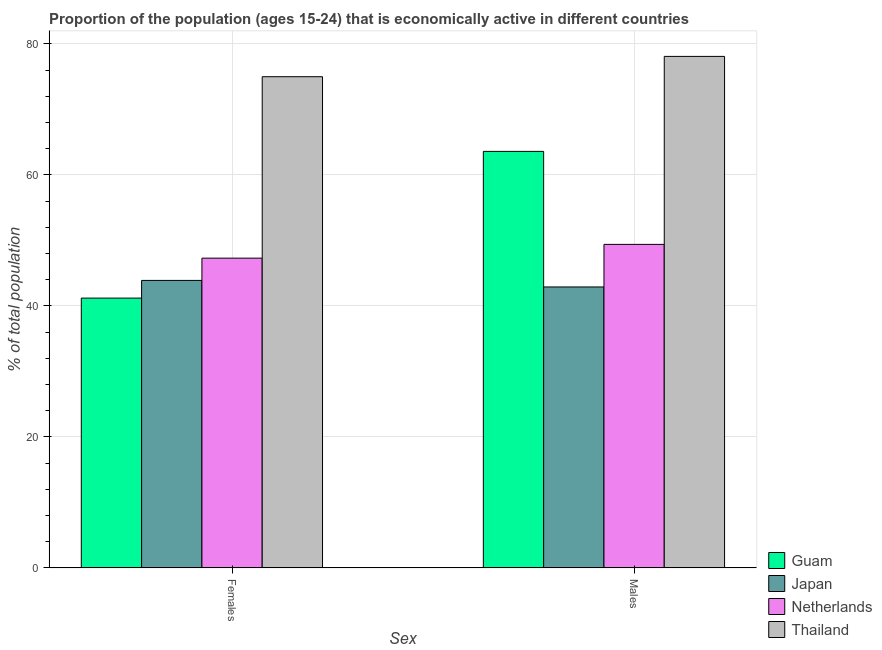How many different coloured bars are there?
Ensure brevity in your answer.  4. Are the number of bars per tick equal to the number of legend labels?
Make the answer very short. Yes. How many bars are there on the 1st tick from the left?
Keep it short and to the point. 4. What is the label of the 2nd group of bars from the left?
Your response must be concise. Males. What is the percentage of economically active male population in Japan?
Provide a short and direct response. 42.9. Across all countries, what is the maximum percentage of economically active male population?
Offer a very short reply. 78.1. Across all countries, what is the minimum percentage of economically active male population?
Ensure brevity in your answer.  42.9. In which country was the percentage of economically active male population maximum?
Provide a short and direct response. Thailand. In which country was the percentage of economically active female population minimum?
Ensure brevity in your answer.  Guam. What is the total percentage of economically active female population in the graph?
Your answer should be very brief. 207.4. What is the difference between the percentage of economically active female population in Thailand and that in Japan?
Your answer should be compact. 31.1. What is the average percentage of economically active male population per country?
Keep it short and to the point. 58.5. In how many countries, is the percentage of economically active female population greater than 8 %?
Ensure brevity in your answer.  4. What is the ratio of the percentage of economically active male population in Japan to that in Guam?
Ensure brevity in your answer.  0.67. In how many countries, is the percentage of economically active female population greater than the average percentage of economically active female population taken over all countries?
Provide a short and direct response. 1. What does the 1st bar from the left in Females represents?
Provide a short and direct response. Guam. What does the 3rd bar from the right in Males represents?
Your answer should be very brief. Japan. How many bars are there?
Offer a terse response. 8. Are the values on the major ticks of Y-axis written in scientific E-notation?
Keep it short and to the point. No. Where does the legend appear in the graph?
Your answer should be very brief. Bottom right. How are the legend labels stacked?
Provide a short and direct response. Vertical. What is the title of the graph?
Your answer should be compact. Proportion of the population (ages 15-24) that is economically active in different countries. What is the label or title of the X-axis?
Your answer should be compact. Sex. What is the label or title of the Y-axis?
Ensure brevity in your answer.  % of total population. What is the % of total population of Guam in Females?
Your answer should be very brief. 41.2. What is the % of total population of Japan in Females?
Your answer should be very brief. 43.9. What is the % of total population in Netherlands in Females?
Make the answer very short. 47.3. What is the % of total population in Guam in Males?
Offer a terse response. 63.6. What is the % of total population in Japan in Males?
Give a very brief answer. 42.9. What is the % of total population of Netherlands in Males?
Your response must be concise. 49.4. What is the % of total population of Thailand in Males?
Offer a terse response. 78.1. Across all Sex, what is the maximum % of total population of Guam?
Offer a very short reply. 63.6. Across all Sex, what is the maximum % of total population of Japan?
Give a very brief answer. 43.9. Across all Sex, what is the maximum % of total population of Netherlands?
Your answer should be compact. 49.4. Across all Sex, what is the maximum % of total population in Thailand?
Provide a succinct answer. 78.1. Across all Sex, what is the minimum % of total population in Guam?
Offer a very short reply. 41.2. Across all Sex, what is the minimum % of total population in Japan?
Ensure brevity in your answer.  42.9. Across all Sex, what is the minimum % of total population in Netherlands?
Provide a succinct answer. 47.3. Across all Sex, what is the minimum % of total population in Thailand?
Ensure brevity in your answer.  75. What is the total % of total population of Guam in the graph?
Provide a succinct answer. 104.8. What is the total % of total population in Japan in the graph?
Offer a very short reply. 86.8. What is the total % of total population in Netherlands in the graph?
Ensure brevity in your answer.  96.7. What is the total % of total population of Thailand in the graph?
Keep it short and to the point. 153.1. What is the difference between the % of total population in Guam in Females and that in Males?
Your answer should be very brief. -22.4. What is the difference between the % of total population in Guam in Females and the % of total population in Japan in Males?
Make the answer very short. -1.7. What is the difference between the % of total population in Guam in Females and the % of total population in Netherlands in Males?
Make the answer very short. -8.2. What is the difference between the % of total population of Guam in Females and the % of total population of Thailand in Males?
Keep it short and to the point. -36.9. What is the difference between the % of total population in Japan in Females and the % of total population in Thailand in Males?
Ensure brevity in your answer.  -34.2. What is the difference between the % of total population in Netherlands in Females and the % of total population in Thailand in Males?
Give a very brief answer. -30.8. What is the average % of total population in Guam per Sex?
Provide a succinct answer. 52.4. What is the average % of total population in Japan per Sex?
Your answer should be very brief. 43.4. What is the average % of total population in Netherlands per Sex?
Give a very brief answer. 48.35. What is the average % of total population in Thailand per Sex?
Your answer should be compact. 76.55. What is the difference between the % of total population of Guam and % of total population of Japan in Females?
Provide a succinct answer. -2.7. What is the difference between the % of total population in Guam and % of total population in Netherlands in Females?
Ensure brevity in your answer.  -6.1. What is the difference between the % of total population in Guam and % of total population in Thailand in Females?
Offer a very short reply. -33.8. What is the difference between the % of total population in Japan and % of total population in Thailand in Females?
Offer a terse response. -31.1. What is the difference between the % of total population in Netherlands and % of total population in Thailand in Females?
Provide a short and direct response. -27.7. What is the difference between the % of total population in Guam and % of total population in Japan in Males?
Provide a succinct answer. 20.7. What is the difference between the % of total population of Japan and % of total population of Netherlands in Males?
Make the answer very short. -6.5. What is the difference between the % of total population of Japan and % of total population of Thailand in Males?
Give a very brief answer. -35.2. What is the difference between the % of total population in Netherlands and % of total population in Thailand in Males?
Provide a succinct answer. -28.7. What is the ratio of the % of total population of Guam in Females to that in Males?
Offer a terse response. 0.65. What is the ratio of the % of total population of Japan in Females to that in Males?
Ensure brevity in your answer.  1.02. What is the ratio of the % of total population in Netherlands in Females to that in Males?
Provide a succinct answer. 0.96. What is the ratio of the % of total population in Thailand in Females to that in Males?
Keep it short and to the point. 0.96. What is the difference between the highest and the second highest % of total population of Guam?
Ensure brevity in your answer.  22.4. What is the difference between the highest and the second highest % of total population in Netherlands?
Provide a short and direct response. 2.1. What is the difference between the highest and the second highest % of total population in Thailand?
Your response must be concise. 3.1. What is the difference between the highest and the lowest % of total population in Guam?
Provide a succinct answer. 22.4. What is the difference between the highest and the lowest % of total population of Japan?
Offer a terse response. 1. What is the difference between the highest and the lowest % of total population in Netherlands?
Provide a short and direct response. 2.1. 